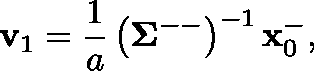<formula> <loc_0><loc_0><loc_500><loc_500>v _ { 1 } = \frac { 1 } { a } \left ( \Sigma ^ { - - } \right ) ^ { - 1 } x _ { 0 } ^ { - } ,</formula> 